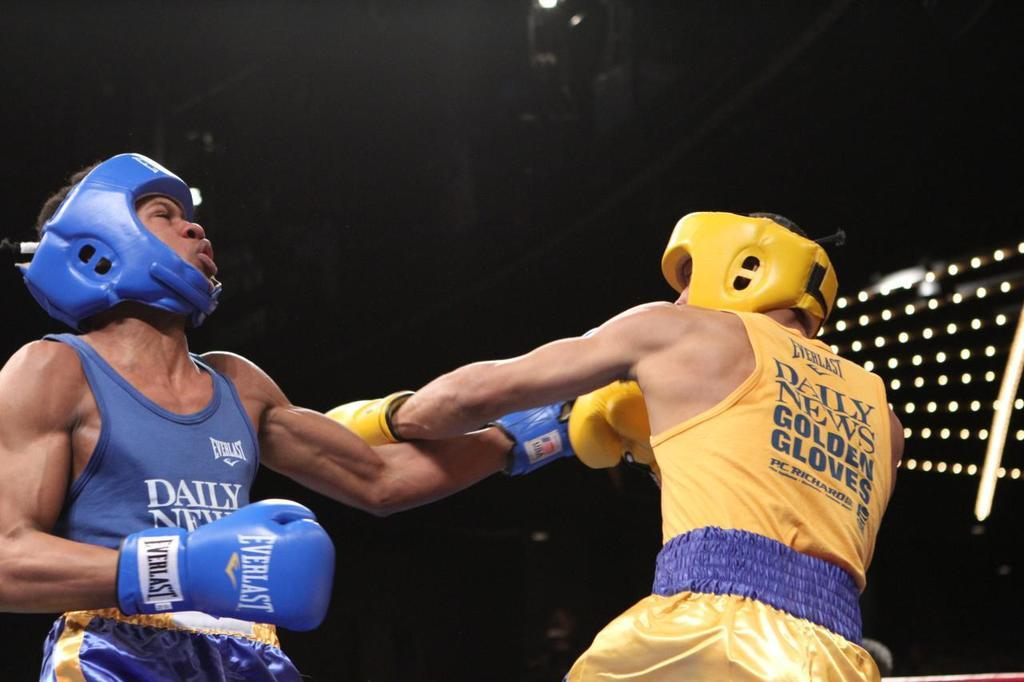<image>
Describe the image concisely. the word daily is on the shirt of a boxer 